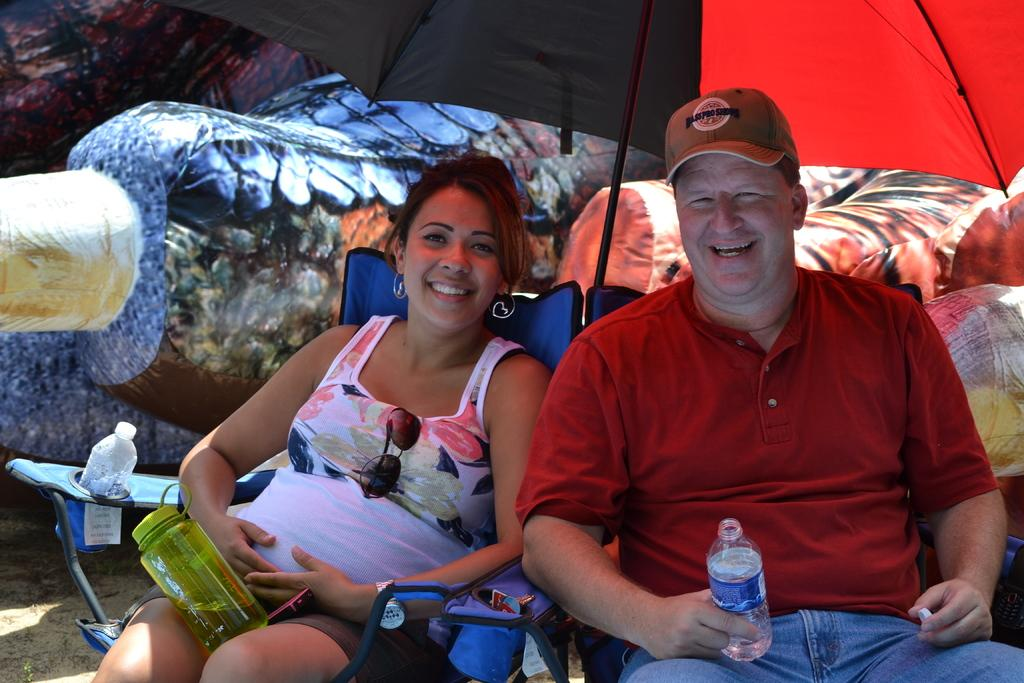How many people are in the image? There are two people in the image. What are the two people doing in the image? The two people are sitting under an umbrella. What type of crown is the writer wearing in the image? There is no writer or crown present in the image. Is there a chain connecting the two people in the image? There is no chain connecting the two people in the image. 